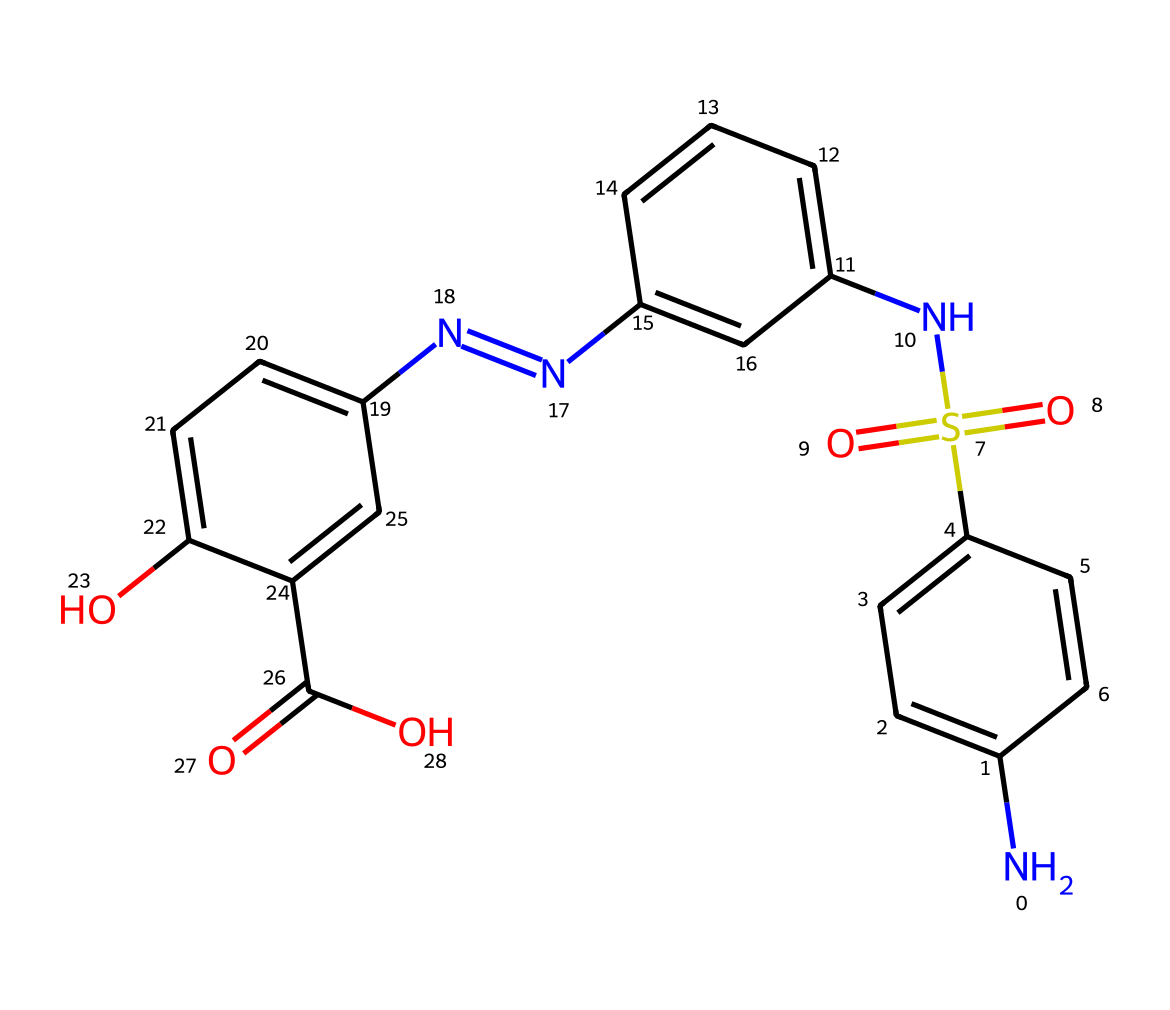What is the molecular formula of sulfasalazine? To determine the molecular formula, we need to count all the atoms in the SMILES provided. The count gives us the number of carbon, hydrogen, nitrogen, oxygen, and sulfur atoms. After parsing the SMILES, the molecular formula comes out to be C18H14N4O5S.
Answer: C18H14N4O5S How many nitrogen atoms are present in sulfasalazine? The number of nitrogen atoms can be determined by identifying and counting the 'N' in the SMILES structure. Scanning through the SMILES shows there are four nitrogen atoms.
Answer: 4 What is the functional group associated with the sulfur in sulfasalazine? The sulfur’s attachment in the SMILES structure is indicated by 'S(=O)(=O)', which reflects the sulfonamide functional group (SO2). This indicates the presence of a sulfonic acid derivative.
Answer: sulfonamide How many rings are present in the chemical structure of sulfasalazine? To identify the rings, look for the cyclic parts of the structure marked by 'c' in the SMILES. By analyzing the structure, we can see that there are three aromatic rings represented.
Answer: 3 What type of compound is sulfasalazine? Sulfasalazine is classified as a sulfonamide anti-inflammatory drug. The presence of the sulfonamide and its use in medicinal chemistry allows us to categorize it effectively.
Answer: sulfonamide Which atoms are directly bonded to sulfur in sulfasalazine? To find the atoms bonded to sulfur, we look for connections to the sulfur atom indicated in the SMILES syntax. The sulfur is connected to two oxygen atoms (O) and a nitrogen atom (N), forming a sulfonamide linkage.
Answer: O and N 